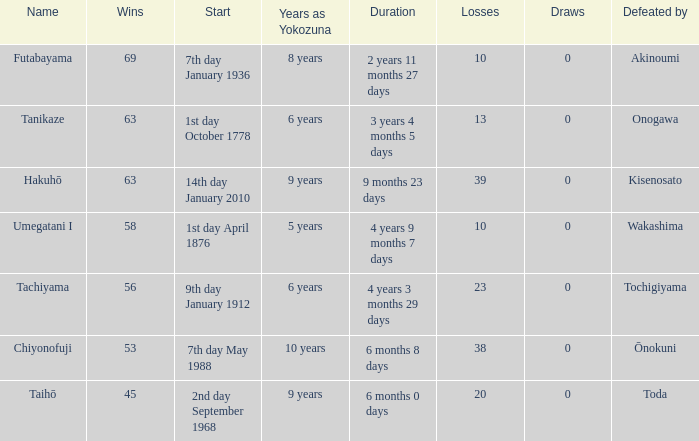How many wins were held before being defeated by toda? 1.0. 